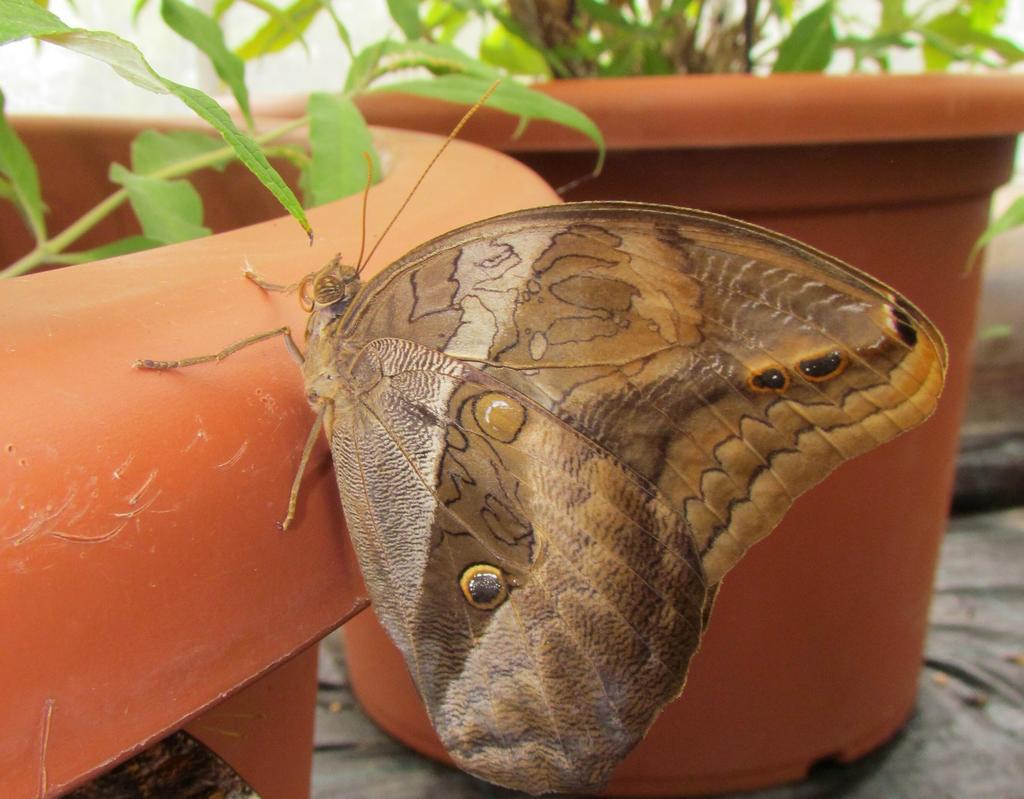Please provide a concise description of this image. In the picture I can see a butterfly. In the background I can see plant pots. The background of the image is blurred. 